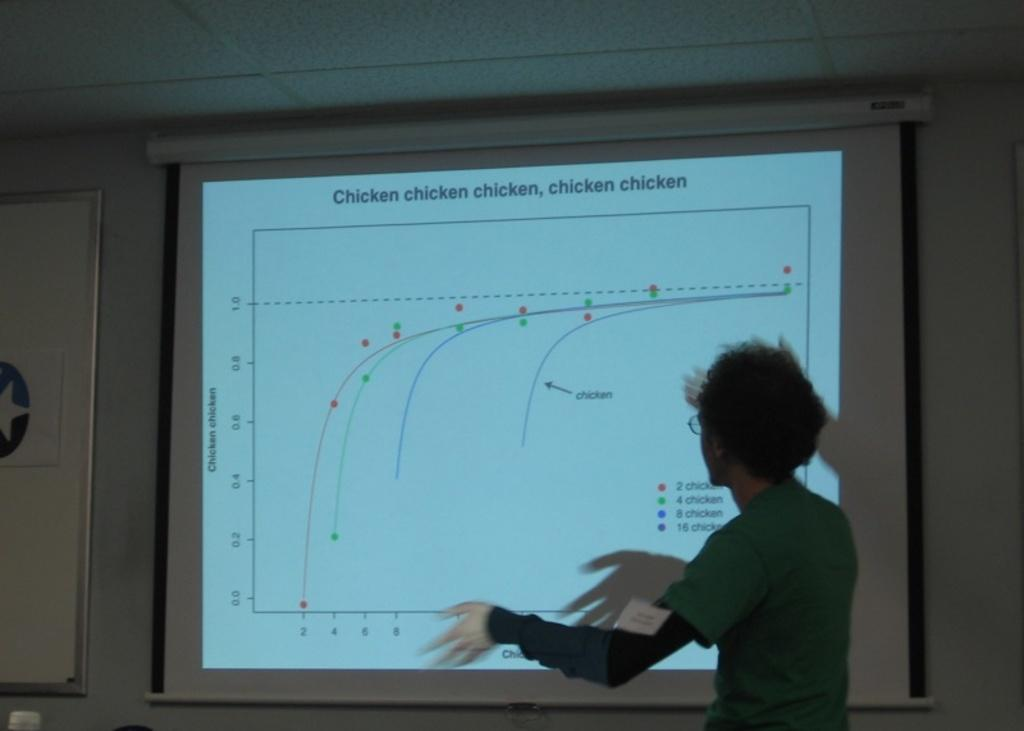<image>
Present a compact description of the photo's key features. A man giving a presentation with the words chicken repeated five times at the header. 